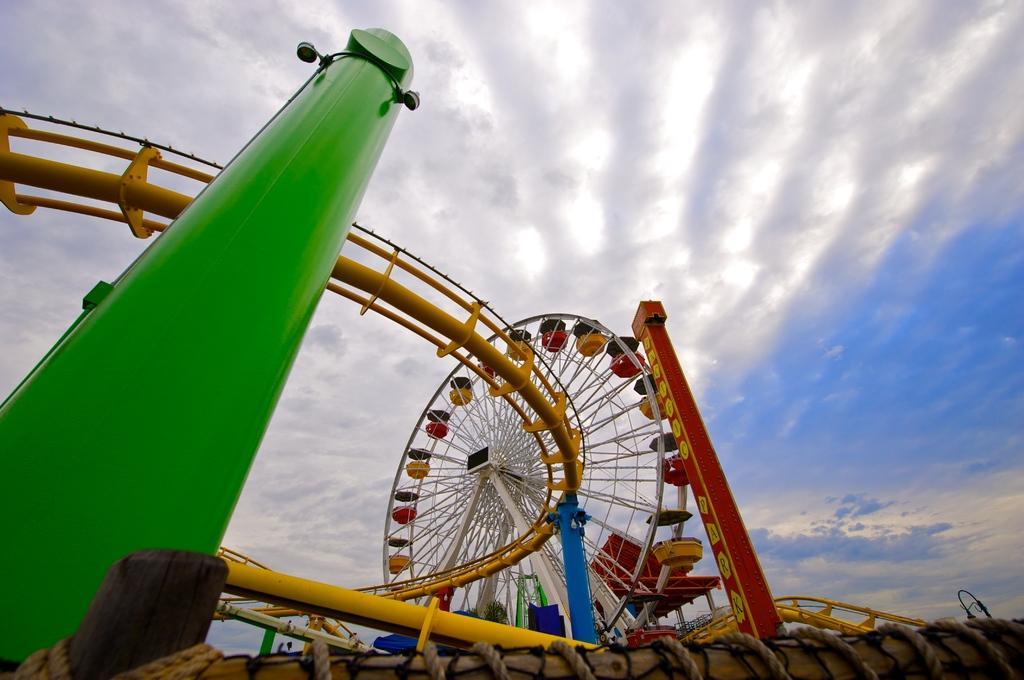How would you summarize this image in a sentence or two? In this picture we can see poles, lights, ropes, rods and giant wheel. In the background of the image we can see sky with clouds. 